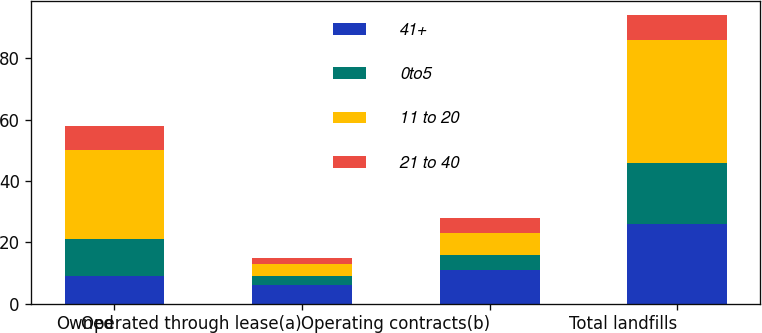<chart> <loc_0><loc_0><loc_500><loc_500><stacked_bar_chart><ecel><fcel>Owned<fcel>Operated through lease(a)<fcel>Operating contracts(b)<fcel>Total landfills<nl><fcel>41+<fcel>9<fcel>6<fcel>11<fcel>26<nl><fcel>0to5<fcel>12<fcel>3<fcel>5<fcel>20<nl><fcel>11 to 20<fcel>29<fcel>4<fcel>7<fcel>40<nl><fcel>21 to 40<fcel>8<fcel>2<fcel>5<fcel>8<nl></chart> 